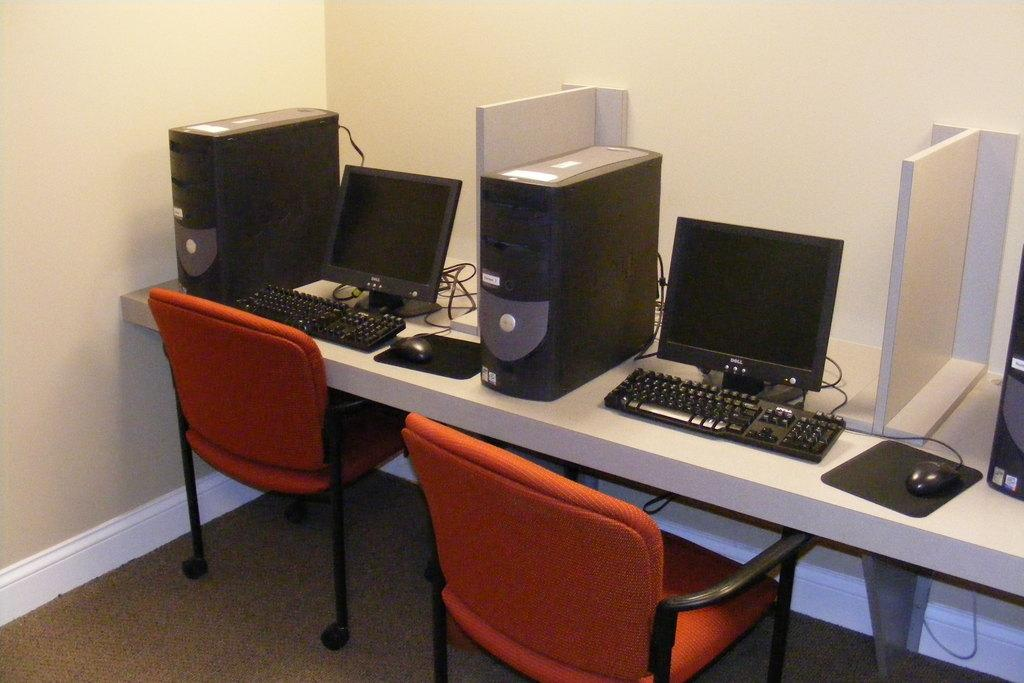What electronic devices are on the table in the image? There are monitors on the table in the image. What other computer component is on the table in the image? There is a CPU on the table in the image. What type of furniture is in front of the table in the image? There are chairs in front of the table in the image. What type of bat can be seen flying around the hospital in the image? There is no bat or hospital present in the image; it features monitors, a CPU, and chairs. 